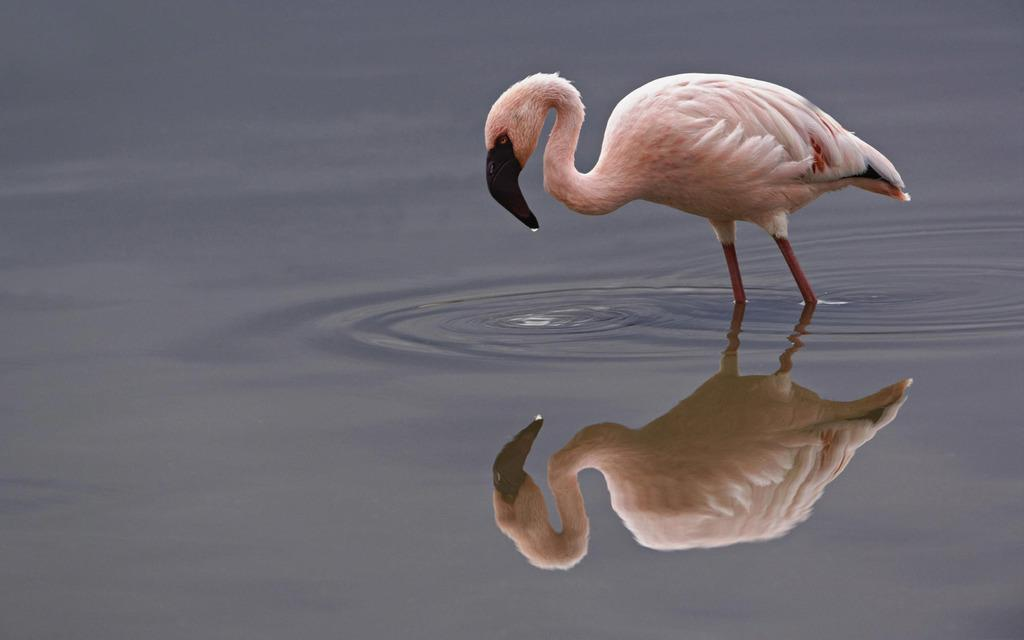What type of animal is present in the image? There is a bird in the image. Can you describe the bird's surroundings? The bird's reflection is visible on the water. Is there a lamp illuminating the bird in the image? There is no mention of a lamp in the image; it features a bird and its reflection on the water. 